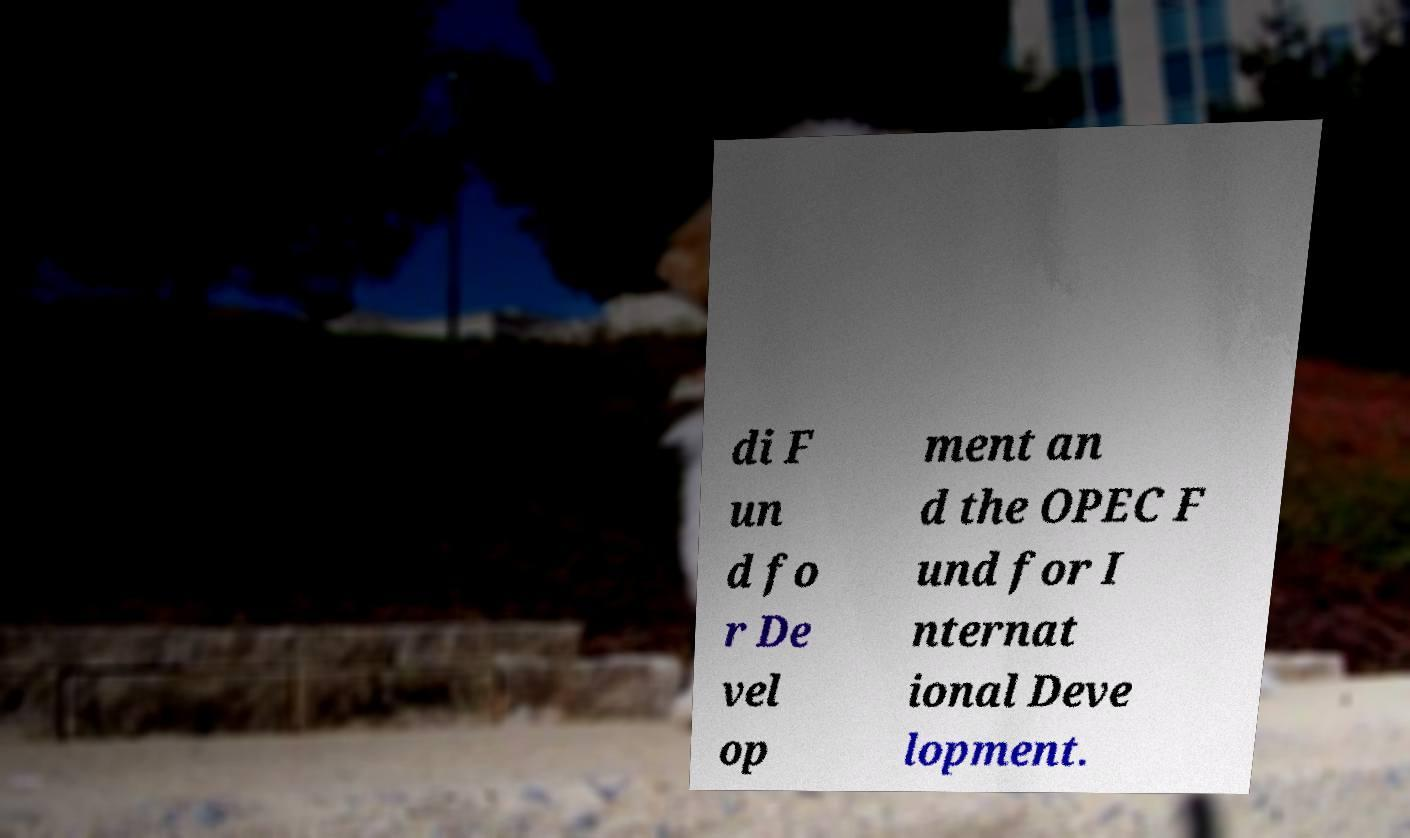Please identify and transcribe the text found in this image. di F un d fo r De vel op ment an d the OPEC F und for I nternat ional Deve lopment. 